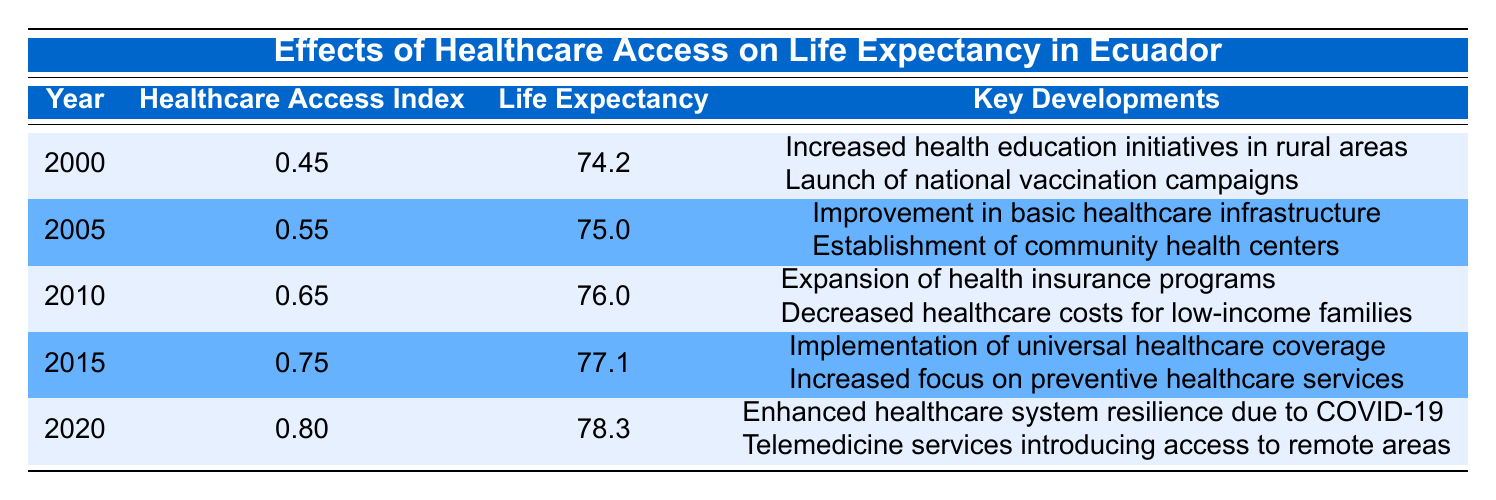What was the healthcare access index in 2015? According to the table, the healthcare access index for the year 2015 is explicitly listed as 0.75.
Answer: 0.75 What was the life expectancy in Ecuador in 2000? The table shows that the life expectancy for the year 2000 is 74.2 years.
Answer: 74.2 In which year was life expectancy the highest? By reviewing the life expectancy figures from the years listed, the highest life expectancy is noted in 2020 at 78.3 years.
Answer: 2020 What is the difference in life expectancy between 2000 and 2020? The life expectancy in 2000 is 74.2 and in 2020 it is 78.3. The difference is calculated as 78.3 - 74.2 = 4.1 years.
Answer: 4.1 Is it true that the healthcare access index in 2010 was higher than 0.60? The table indicates that the healthcare access index in 2010 was 0.65, which is indeed higher than 0.60.
Answer: Yes What was the average healthcare access index from 2000 to 2020? To calculate the average, we sum the healthcare access indices for each year (0.45 + 0.55 + 0.65 + 0.75 + 0.80 = 3.20) and divide by the number of years (5), resulting in an average of 3.20 / 5 = 0.64.
Answer: 0.64 What were the key developments for healthcare in 2015? The table states that in 2015, the key developments included the implementation of universal healthcare coverage and increased focus on preventive healthcare services.
Answer: Implementation of universal healthcare coverage and increased focus on preventive healthcare services How did the life expectancy change from 2010 to 2020? The life expectancy in 2010 was 76.0 and in 2020 it increased to 78.3. The change is calculated as 78.3 - 76.0 = 2.3 years, indicating an improvement.
Answer: 2.3 years Was there an increase in life expectancy every five years? Reviewing the life expectancy values from 2000 to 2020 (74.2, 75.0, 76.0, 77.1, 78.3), there was indeed an increase every five years, confirming the trend of improvement.
Answer: Yes 